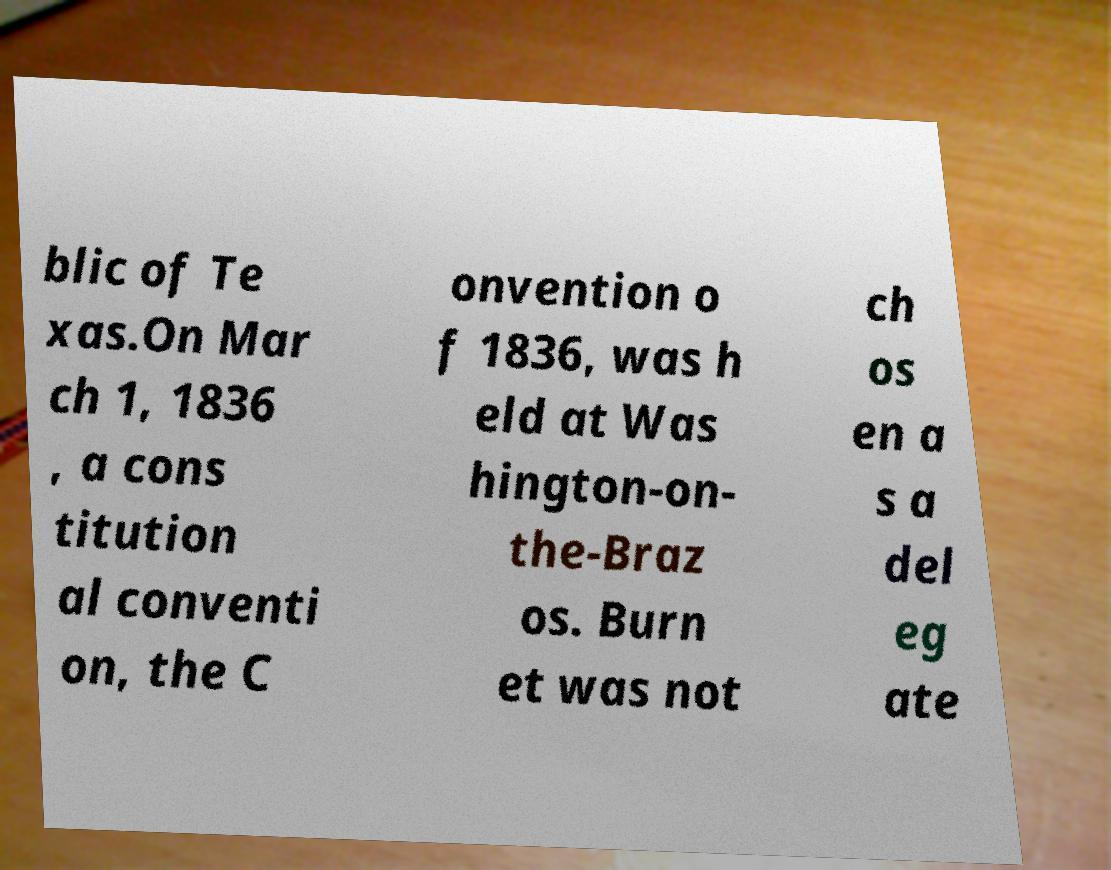Can you read and provide the text displayed in the image?This photo seems to have some interesting text. Can you extract and type it out for me? blic of Te xas.On Mar ch 1, 1836 , a cons titution al conventi on, the C onvention o f 1836, was h eld at Was hington-on- the-Braz os. Burn et was not ch os en a s a del eg ate 